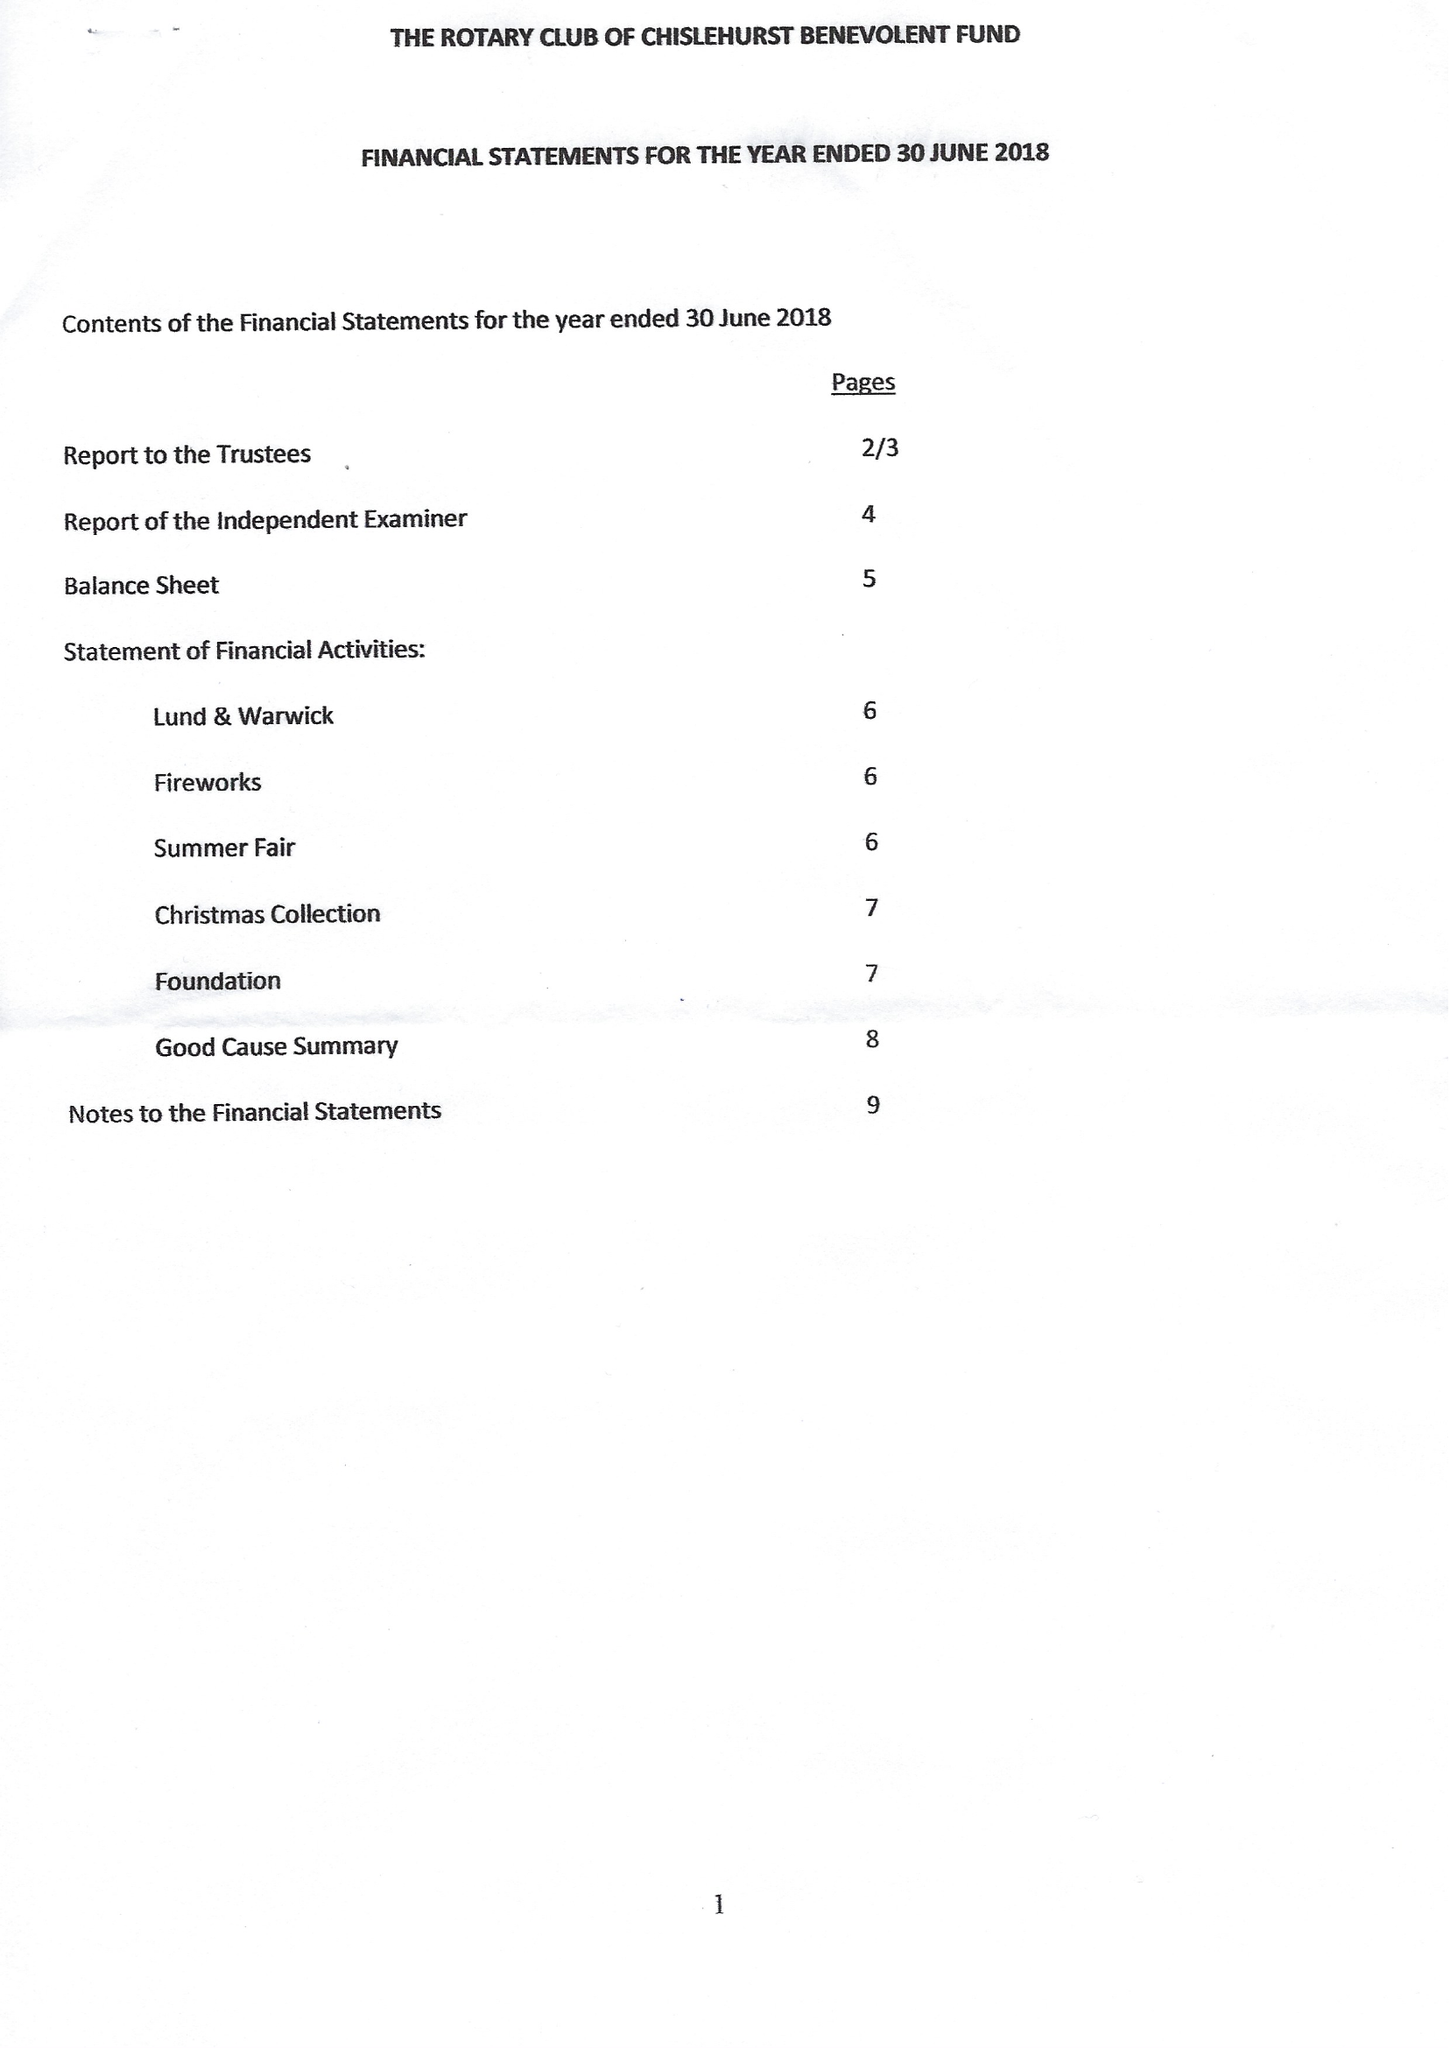What is the value for the address__postcode?
Answer the question using a single word or phrase. BR6 7RS 